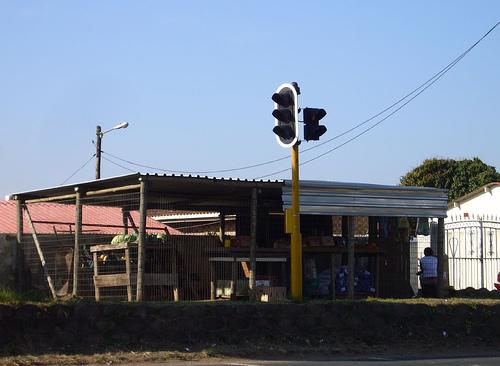What kind of roof is on the house?
Keep it brief. Metal. What is behind the light?
Quick response, please. Building. What color is the man's shirt?
Quick response, please. White. What color is the stop light pole?
Write a very short answer. Yellow. Is there a person in the picture?
Concise answer only. Yes. 